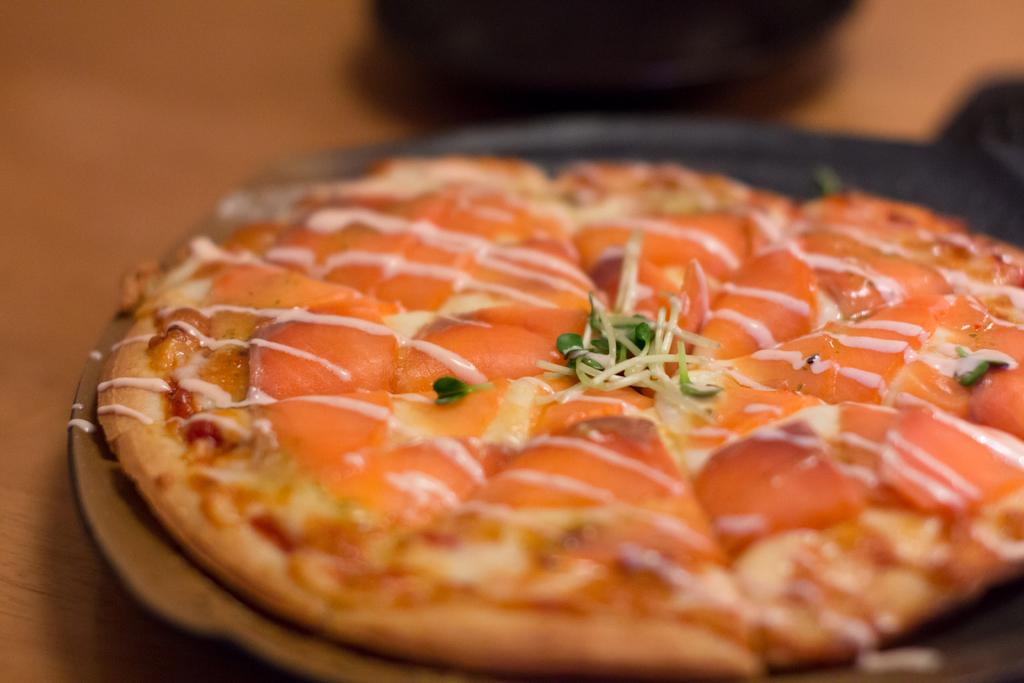What type of food item is depicted in the image? There is a food item in the image that looks like pizza. How is the food item presented in the image? The food item is on a plate. Where is the plate with the food item located? The plate is placed on a table. What can be seen at the top of the image? There are objects visible at the top of the image. How many goldfish are swimming in the plate with the pizza? There are no goldfish present in the image; it features a plate with a food item that resembles pizza. 